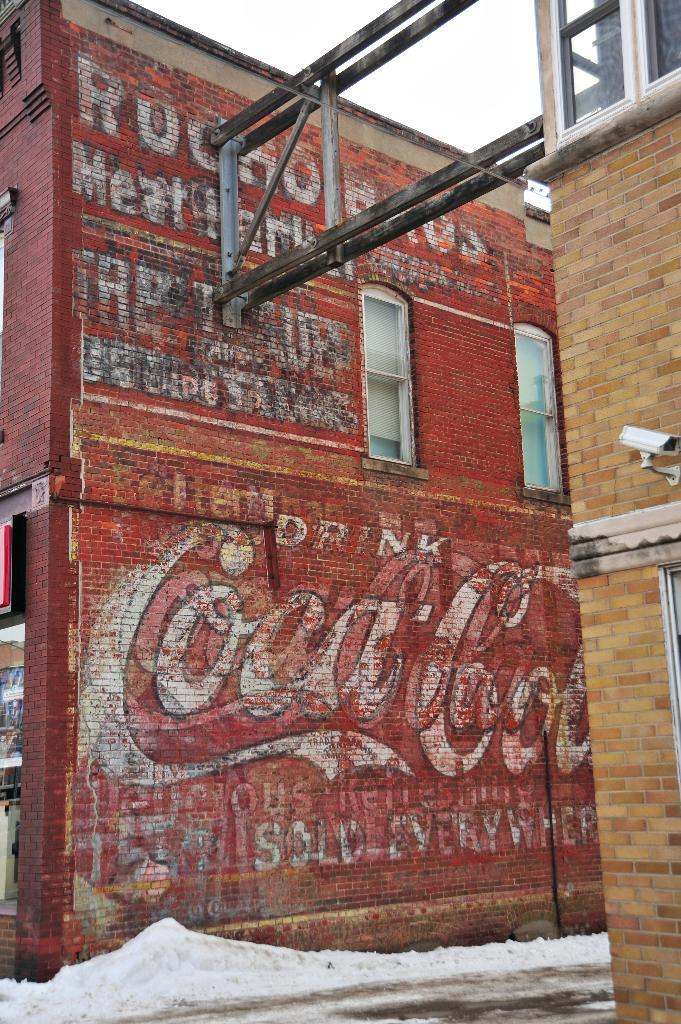What type of structure is visible in the image? There is a building in the image. What feature of the building is mentioned in the facts? The building has windows. What security feature is present in the image? A CCTV camera is present in the image. What type of objects can be seen near the building? There are rods in the image. What part of the natural environment is visible in the image? The sky is visible in the image. What is written on a specific color in the image? Something is written on a red wall in the image. How many dinosaurs can be seen in the image? There are no dinosaurs present in the image. What type of cannon is located near the red wall? There is no cannon present in the image. 